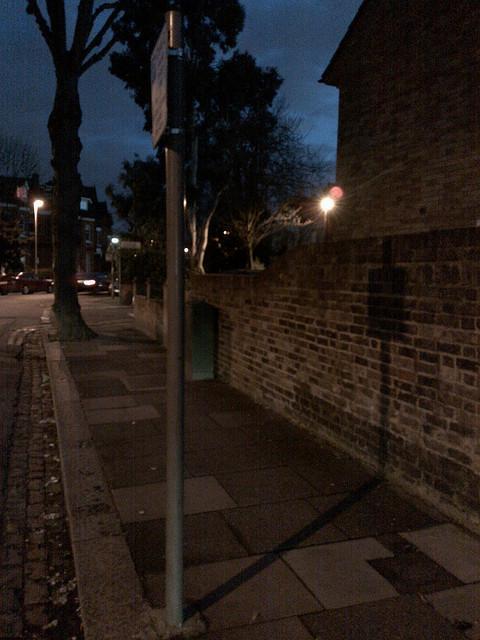How many elephants are in the scene?
Give a very brief answer. 0. 